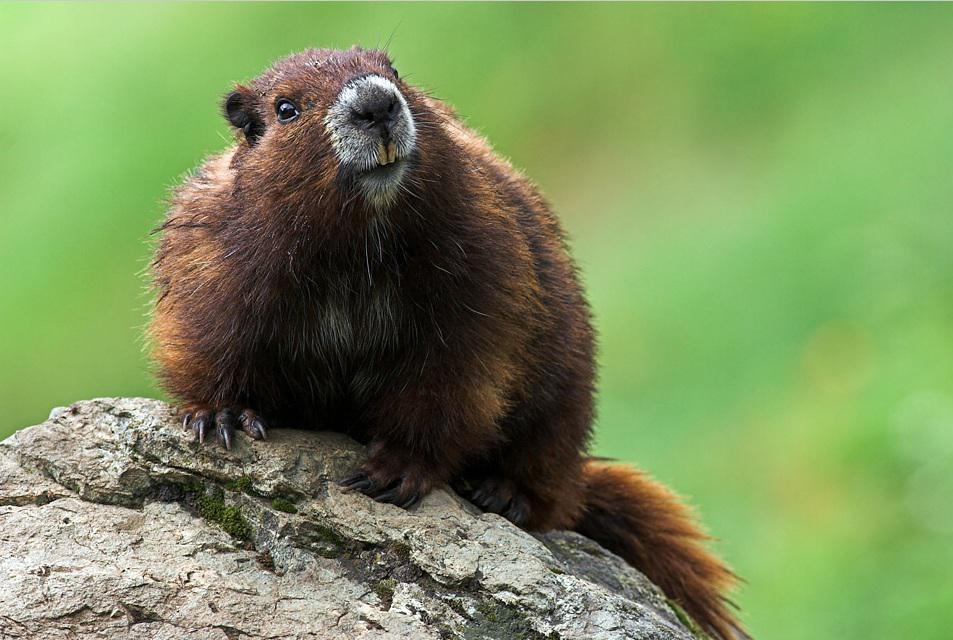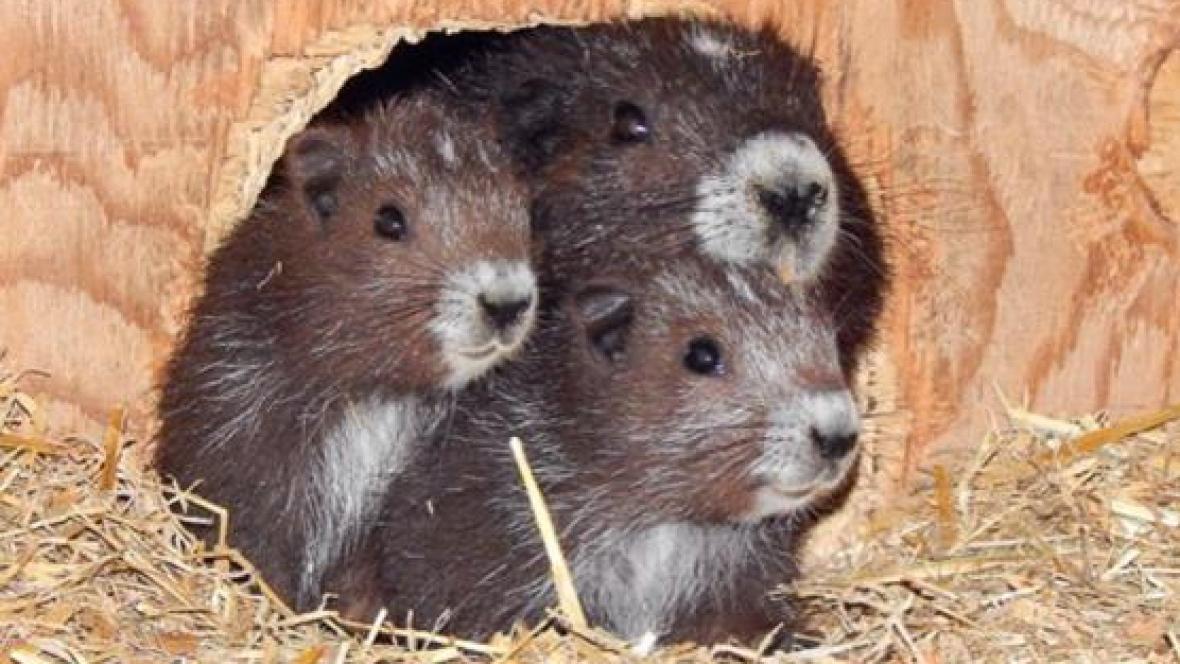The first image is the image on the left, the second image is the image on the right. Evaluate the accuracy of this statement regarding the images: "One image depicts an adult animal and at least one younger rodent.". Is it true? Answer yes or no. Yes. 